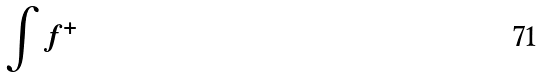Convert formula to latex. <formula><loc_0><loc_0><loc_500><loc_500>\int f ^ { + }</formula> 